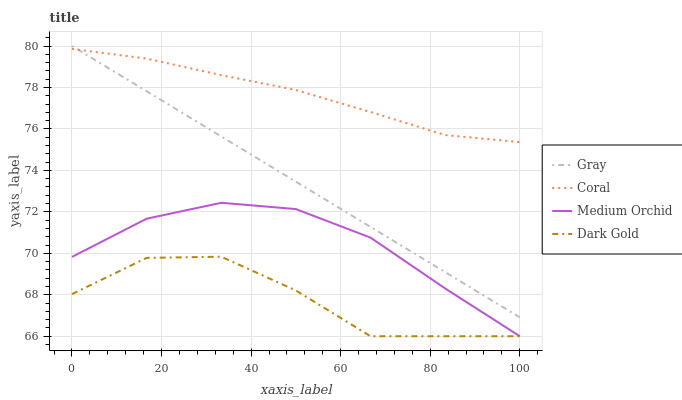Does Dark Gold have the minimum area under the curve?
Answer yes or no. Yes. Does Coral have the maximum area under the curve?
Answer yes or no. Yes. Does Medium Orchid have the minimum area under the curve?
Answer yes or no. No. Does Medium Orchid have the maximum area under the curve?
Answer yes or no. No. Is Gray the smoothest?
Answer yes or no. Yes. Is Dark Gold the roughest?
Answer yes or no. Yes. Is Coral the smoothest?
Answer yes or no. No. Is Coral the roughest?
Answer yes or no. No. Does Coral have the lowest value?
Answer yes or no. No. Does Coral have the highest value?
Answer yes or no. No. Is Dark Gold less than Coral?
Answer yes or no. Yes. Is Coral greater than Medium Orchid?
Answer yes or no. Yes. Does Dark Gold intersect Coral?
Answer yes or no. No. 